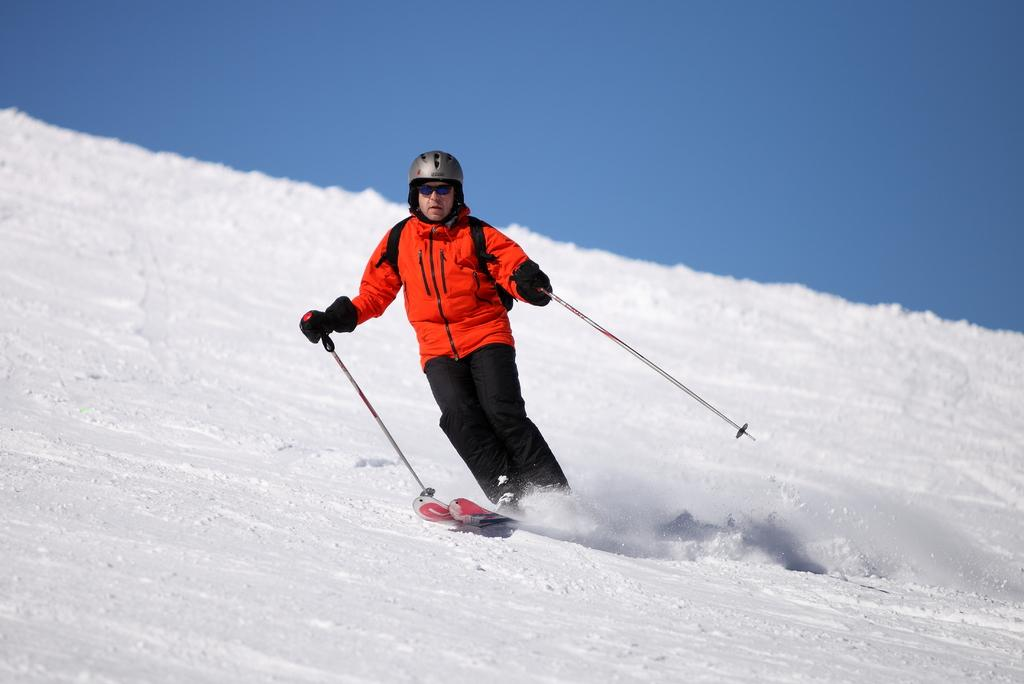What is the main subject of the image? There is a person in the center of the image. What is the person holding? The person is holding sticks. What is the person doing while holding the sticks? The person is on a skateboard and skating. What is the ground made of in the image? There is snow at the bottom of the image. What is visible at the top of the image? The sky is visible at the top of the image. Can you hear the person laughing while skating in the image? There is no sound present in the image, so it is not possible to determine if the person is laughing or not. 